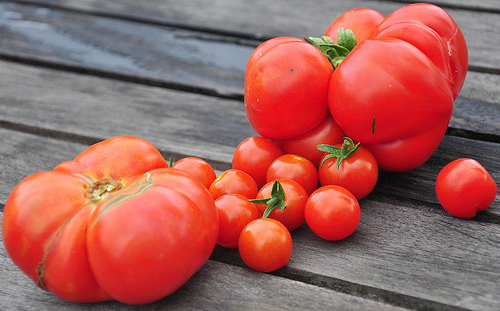<image>
Is the tomato on the desk? Yes. Looking at the image, I can see the tomato is positioned on top of the desk, with the desk providing support. Is the cherry tomato on the table? Yes. Looking at the image, I can see the cherry tomato is positioned on top of the table, with the table providing support. 